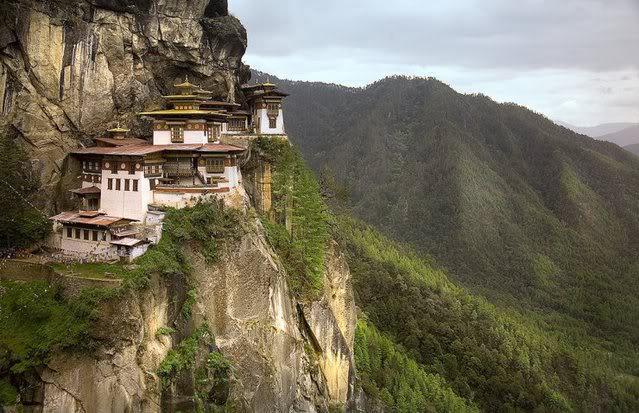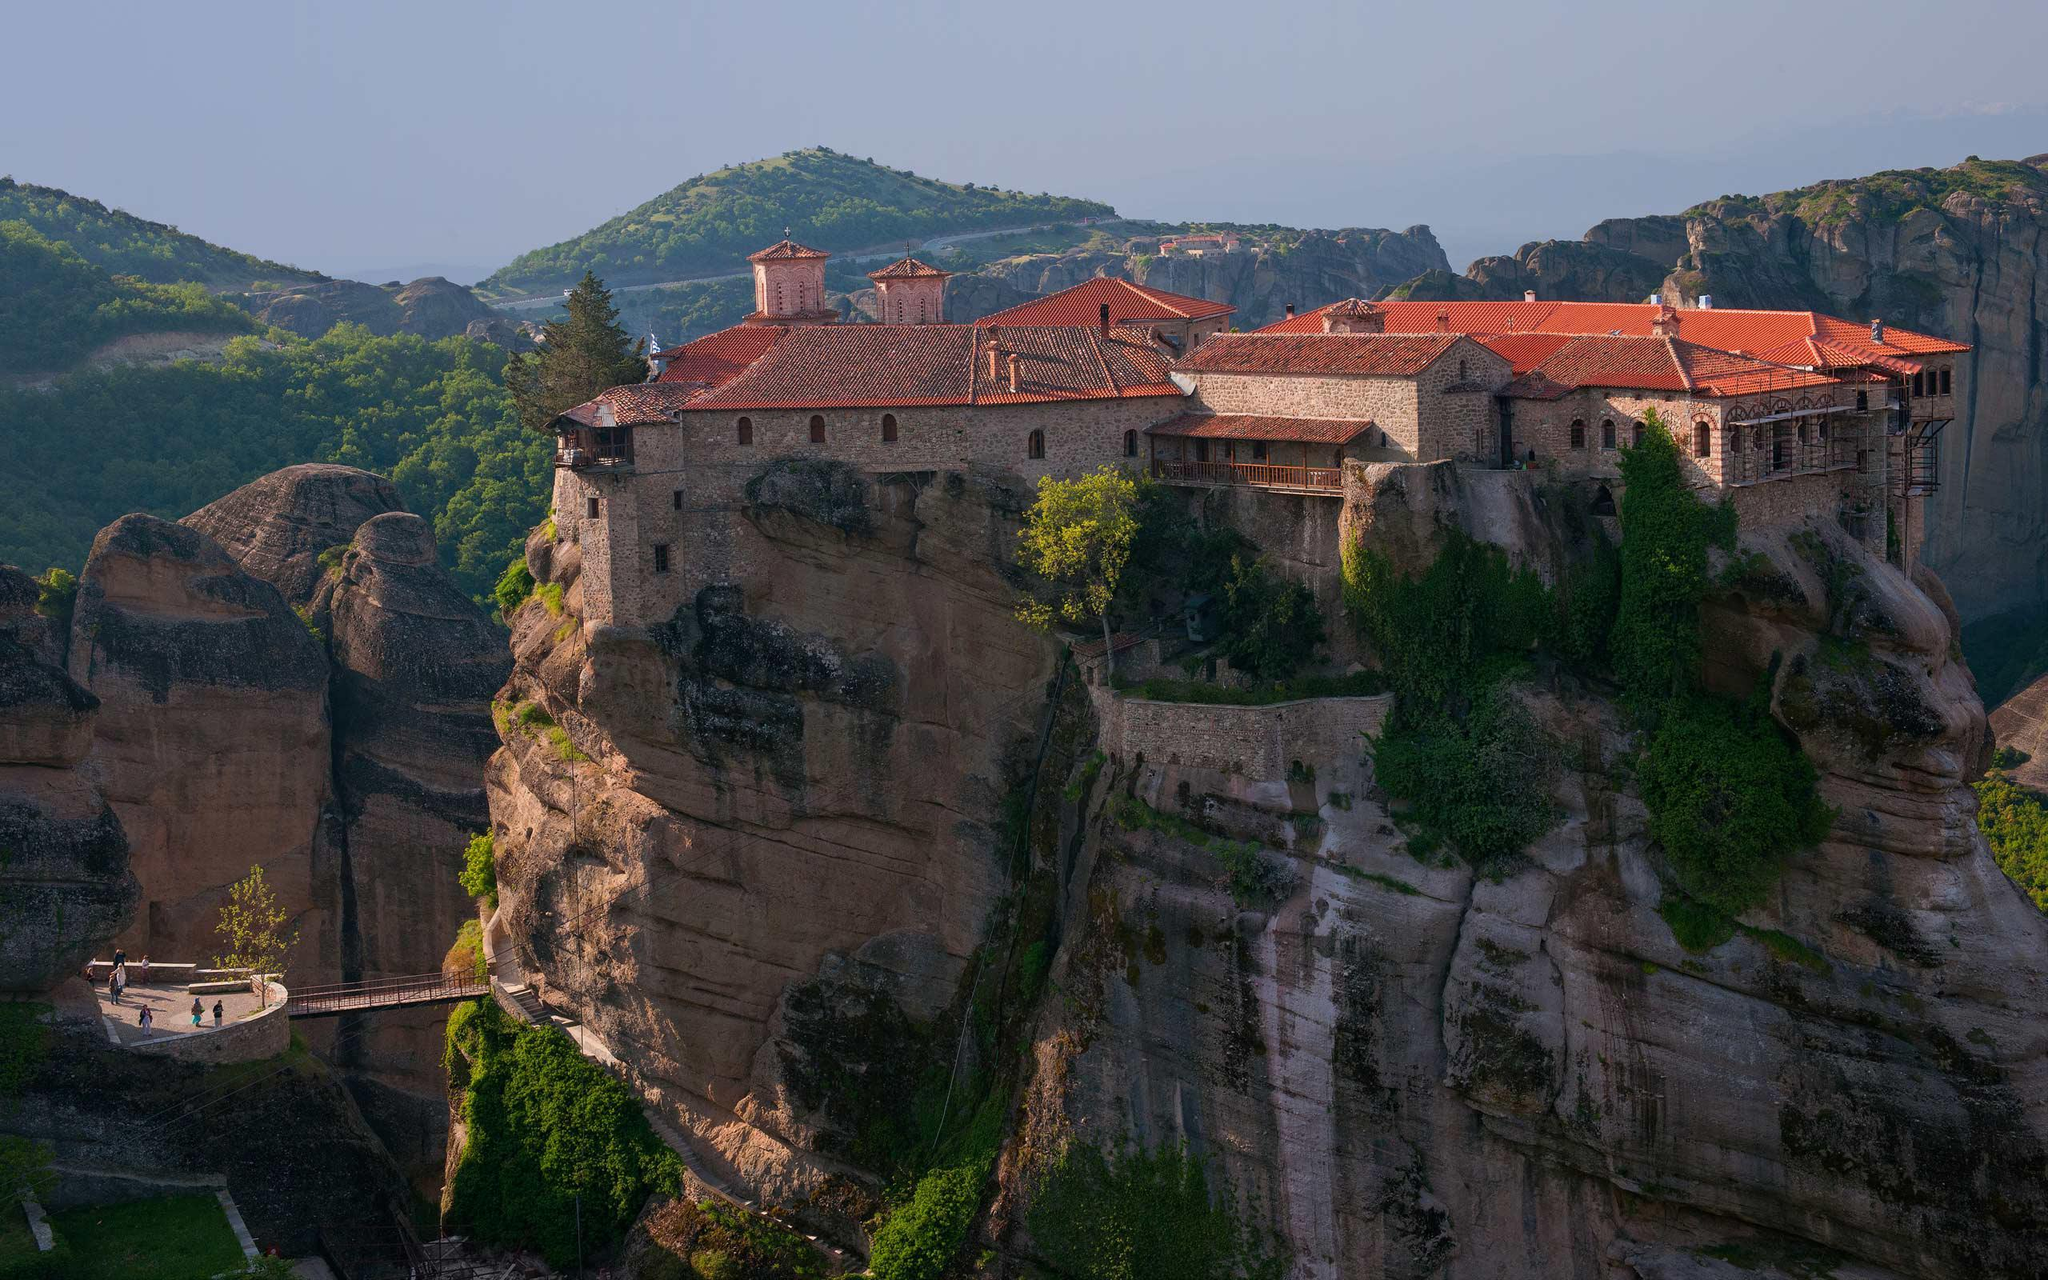The first image is the image on the left, the second image is the image on the right. Evaluate the accuracy of this statement regarding the images: "Right image features buildings with red-orange roofs on a rocky hilltop, while left image does not.". Is it true? Answer yes or no. Yes. 